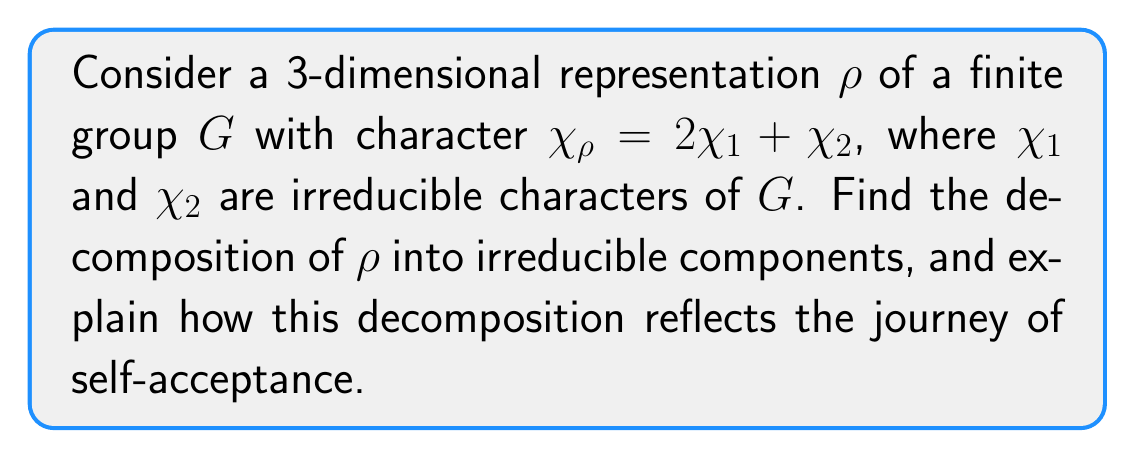Give your solution to this math problem. To find the decomposition of $\rho$ into irreducible components, we follow these steps:

1) The character $\chi_\rho$ is given as a linear combination of irreducible characters:
   $$\chi_\rho = 2\chi_1 + \chi_2$$

2) This tells us that $\rho$ is isomorphic to the direct sum of irreducible representations whose characters are $\chi_1$ (appearing twice) and $\chi_2$ (appearing once).

3) Let $V_1$ and $V_2$ be the irreducible representations corresponding to $\chi_1$ and $\chi_2$ respectively. Then:
   $$\rho \cong V_1 \oplus V_1 \oplus V_2$$

4) This decomposition shows that $\rho$ splits into three parts: two copies of $V_1$ and one copy of $V_2$.

5) In the context of self-acceptance, we can interpret this decomposition as follows:
   - The two copies of $V_1$ represent repeated patterns or beliefs that have contributed to low self-esteem.
   - $V_2$ represents a new perspective or realization that leads to self-acceptance.
   - The process of decomposing $\rho$ into these components mirrors the journey of self-discovery and acceptance, where one identifies and separates different aspects of their self-image.

6) Just as the representation $\rho$ is fully understood through its irreducible components, a person's journey to self-acceptance involves understanding the different facets of their identity and experiences.
Answer: $\rho \cong V_1 \oplus V_1 \oplus V_2$ 